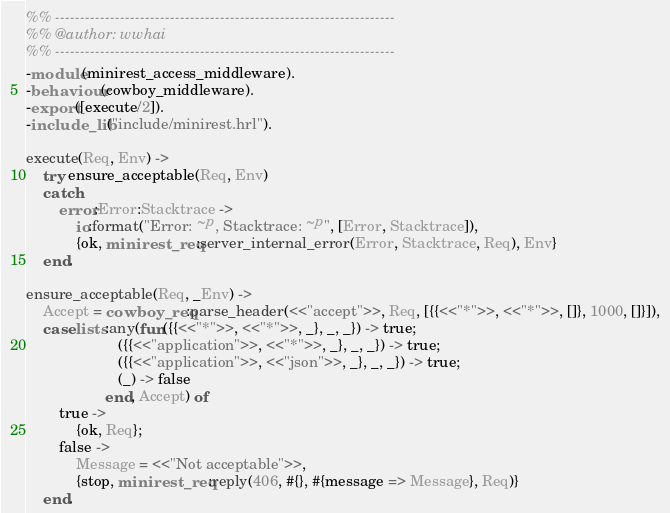Convert code to text. <code><loc_0><loc_0><loc_500><loc_500><_Erlang_>%% --------------------------------------------------------------------
%% @author: wwhai
%% --------------------------------------------------------------------
-module(minirest_access_middleware).
-behaviour(cowboy_middleware).
-export([execute/2]).
-include_lib("include/minirest.hrl").

execute(Req, Env) ->
    try ensure_acceptable(Req, Env)
    catch
        error:Error:Stacktrace ->
            io:format("Error: ~p, Stacktrace: ~p", [Error, Stacktrace]),
            {ok, minirest_req:server_internal_error(Error, Stacktrace, Req), Env}
    end.

ensure_acceptable(Req, _Env) ->
    Accept = cowboy_req:parse_header(<<"accept">>, Req, [{{<<"*">>, <<"*">>, []}, 1000, []}]),
    case lists:any(fun({{<<"*">>, <<"*">>, _}, _, _}) -> true;
                      ({{<<"application">>, <<"*">>, _}, _, _}) -> true;
                      ({{<<"application">>, <<"json">>, _}, _, _}) -> true;
                      (_) -> false
                   end, Accept) of
        true ->
            {ok, Req};
        false ->
            Message = <<"Not acceptable">>,
            {stop, minirest_req:reply(406, #{}, #{message => Message}, Req)}
    end.
</code> 